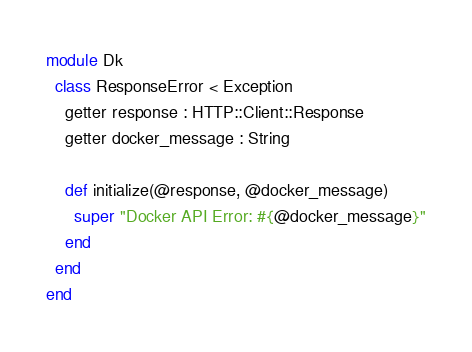Convert code to text. <code><loc_0><loc_0><loc_500><loc_500><_Crystal_>module Dk
  class ResponseError < Exception
    getter response : HTTP::Client::Response
    getter docker_message : String

    def initialize(@response, @docker_message)
      super "Docker API Error: #{@docker_message}"
    end
  end
end
</code> 